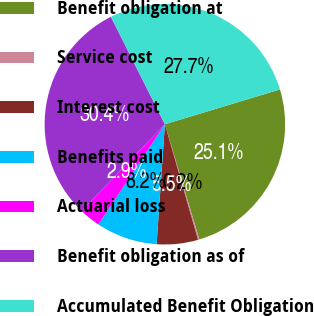Convert chart. <chart><loc_0><loc_0><loc_500><loc_500><pie_chart><fcel>Benefit obligation at<fcel>Service cost<fcel>Interest cost<fcel>Benefits paid<fcel>Actuarial loss<fcel>Benefit obligation as of<fcel>Accumulated Benefit Obligation<nl><fcel>25.05%<fcel>0.18%<fcel>5.54%<fcel>8.22%<fcel>2.86%<fcel>30.41%<fcel>27.73%<nl></chart> 